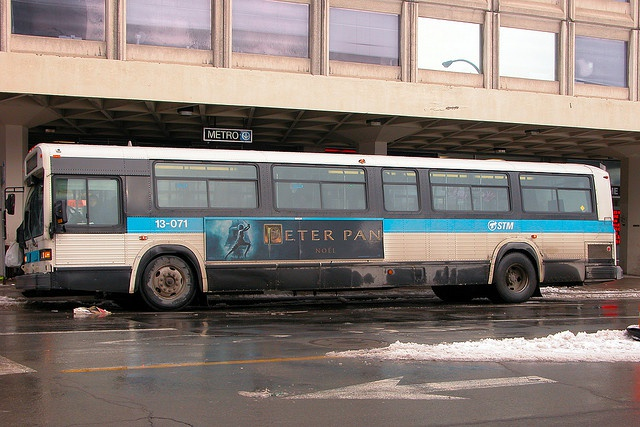Describe the objects in this image and their specific colors. I can see bus in gray, black, darkgray, and white tones in this image. 